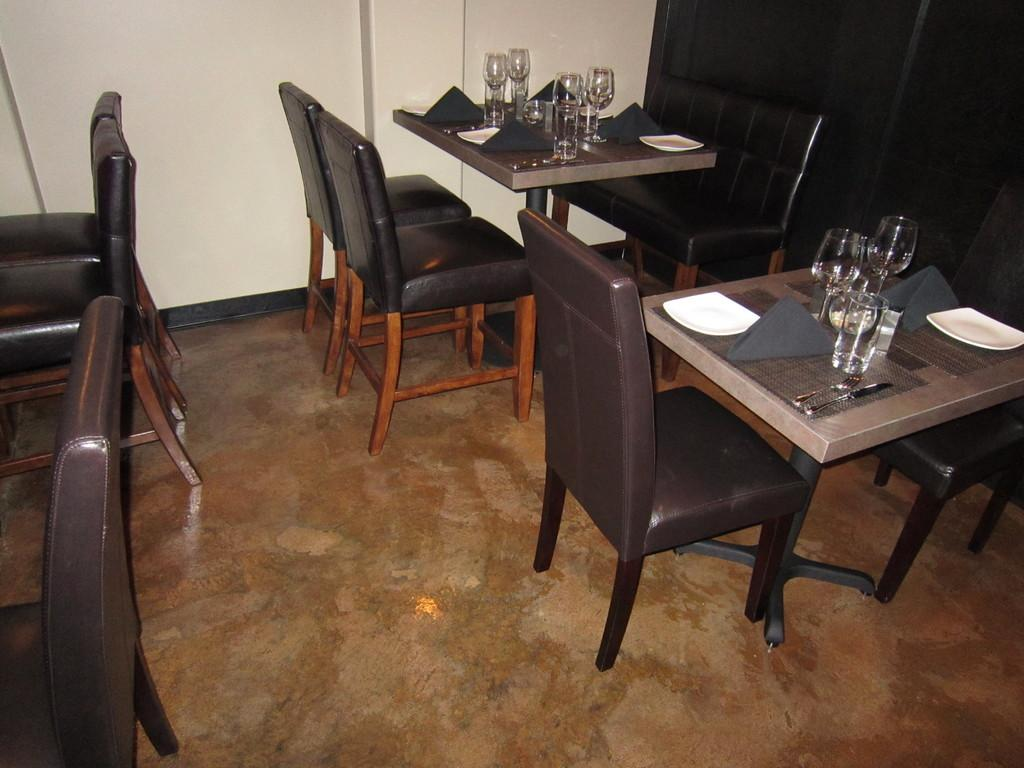What type of objects are on the table in the image? There are glasses, plates, and knives on the table in the image. Are there any other objects on the table besides the ones mentioned? Yes, there are other unspecified things on the table. What type of furniture is visible in the image? There are chairs in the image. How many potatoes can be seen on the table in the image? There is no mention of potatoes in the image, so it cannot be determined how many are present. 